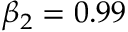Convert formula to latex. <formula><loc_0><loc_0><loc_500><loc_500>\beta _ { 2 } = 0 . 9 9</formula> 